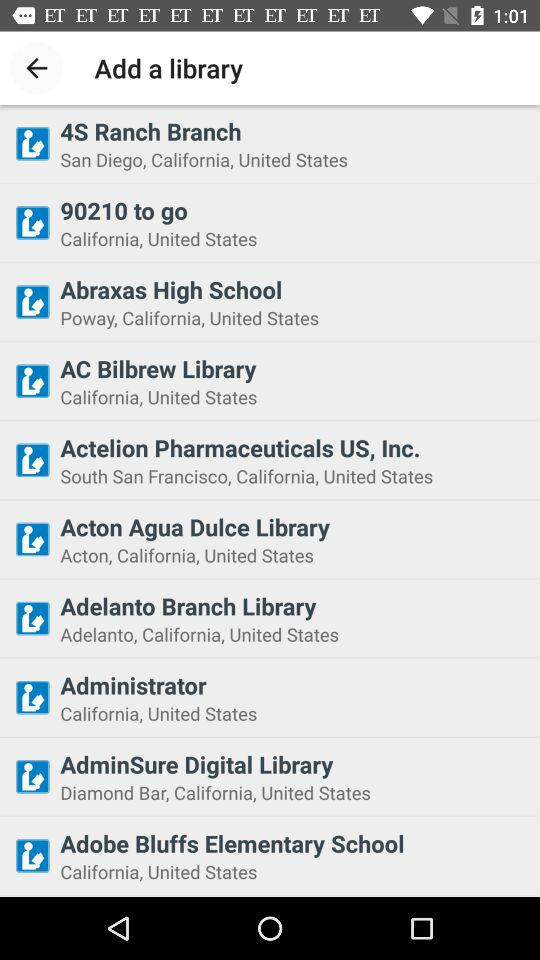What libraries are located in California? The libraries that are located in California are "4S Ranch Branch", "90210 to go", "Abraxas High School", "AC Bilbrew Library", "Actelion Pharmaceuticals US, Inc.", "Acton Agua Dulce Library", "Adelanto Branch Library", "Administrator", "AdminSure Digital Library" and "Adobe Bluffs Elementary School". 